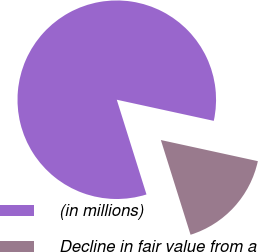Convert chart. <chart><loc_0><loc_0><loc_500><loc_500><pie_chart><fcel>(in millions)<fcel>Decline in fair value from a<nl><fcel>83.25%<fcel>16.75%<nl></chart> 